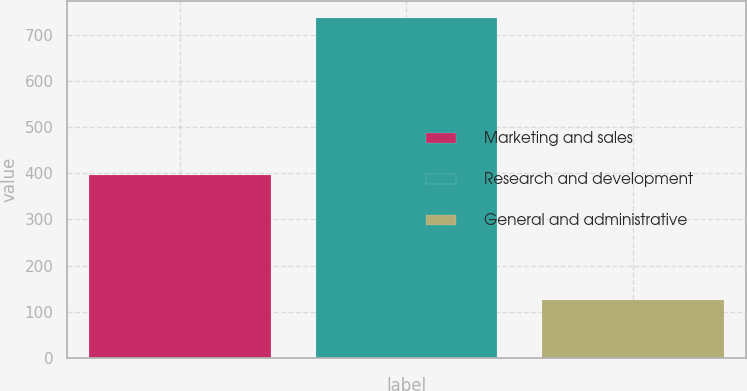Convert chart to OTSL. <chart><loc_0><loc_0><loc_500><loc_500><bar_chart><fcel>Marketing and sales<fcel>Research and development<fcel>General and administrative<nl><fcel>395.2<fcel>735.3<fcel>125.1<nl></chart> 